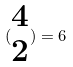Convert formula to latex. <formula><loc_0><loc_0><loc_500><loc_500>( \begin{matrix} 4 \\ 2 \end{matrix} ) = 6</formula> 